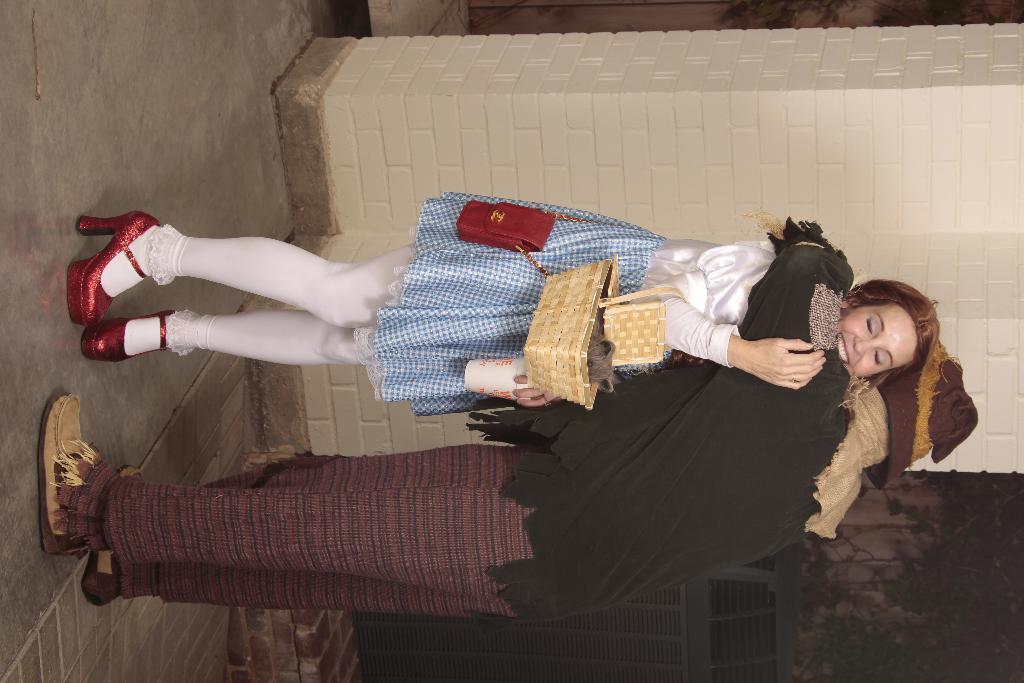How would you summarize this image in a sentence or two? In this image I can see two persons are standing and hugging each other among them this woman is holding a basket and smiling. In the background I can see a brick wall. 